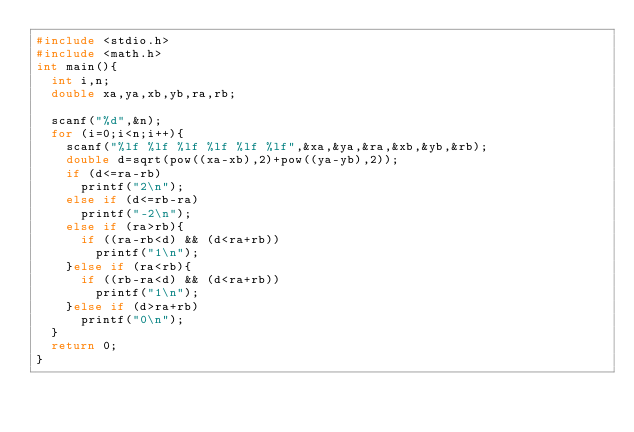<code> <loc_0><loc_0><loc_500><loc_500><_C_>#include <stdio.h>
#include <math.h>
int main(){
  int i,n;
  double xa,ya,xb,yb,ra,rb;

  scanf("%d",&n);
  for (i=0;i<n;i++){
    scanf("%lf %lf %lf %lf %lf %lf",&xa,&ya,&ra,&xb,&yb,&rb);
    double d=sqrt(pow((xa-xb),2)+pow((ya-yb),2));
    if (d<=ra-rb)
      printf("2\n");
    else if (d<=rb-ra)
      printf("-2\n");
    else if (ra>rb){
      if ((ra-rb<d) && (d<ra+rb))
        printf("1\n");
    }else if (ra<rb){
      if ((rb-ra<d) && (d<ra+rb))
        printf("1\n");
    }else if (d>ra+rb)
      printf("0\n");
  }
  return 0;
}</code> 